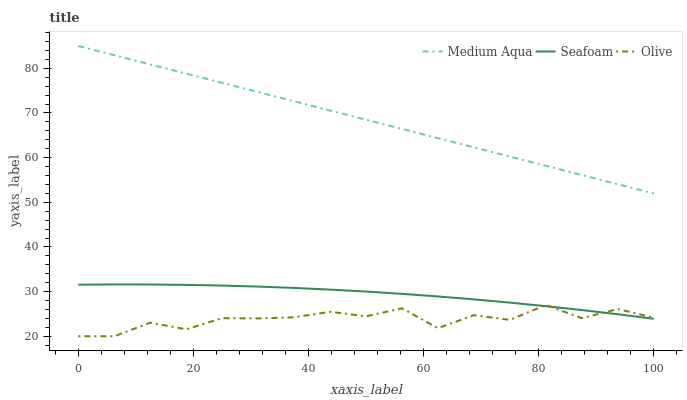Does Olive have the minimum area under the curve?
Answer yes or no. Yes. Does Medium Aqua have the maximum area under the curve?
Answer yes or no. Yes. Does Seafoam have the minimum area under the curve?
Answer yes or no. No. Does Seafoam have the maximum area under the curve?
Answer yes or no. No. Is Medium Aqua the smoothest?
Answer yes or no. Yes. Is Olive the roughest?
Answer yes or no. Yes. Is Seafoam the smoothest?
Answer yes or no. No. Is Seafoam the roughest?
Answer yes or no. No. Does Olive have the lowest value?
Answer yes or no. Yes. Does Seafoam have the lowest value?
Answer yes or no. No. Does Medium Aqua have the highest value?
Answer yes or no. Yes. Does Seafoam have the highest value?
Answer yes or no. No. Is Seafoam less than Medium Aqua?
Answer yes or no. Yes. Is Medium Aqua greater than Seafoam?
Answer yes or no. Yes. Does Seafoam intersect Olive?
Answer yes or no. Yes. Is Seafoam less than Olive?
Answer yes or no. No. Is Seafoam greater than Olive?
Answer yes or no. No. Does Seafoam intersect Medium Aqua?
Answer yes or no. No. 